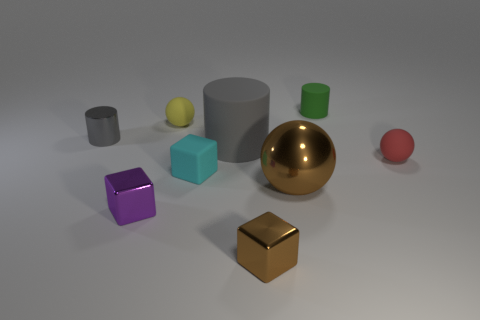What is the small object that is left of the small cyan matte cube and in front of the small gray object made of?
Offer a terse response. Metal. The big shiny ball has what color?
Provide a short and direct response. Brown. Are there more tiny cyan objects in front of the metal cylinder than large gray objects that are behind the big matte cylinder?
Make the answer very short. Yes. The rubber cylinder that is in front of the tiny gray metal thing is what color?
Your answer should be compact. Gray. Do the gray thing that is right of the small yellow rubber ball and the ball left of the big gray matte thing have the same size?
Make the answer very short. No. What number of objects are yellow matte things or small red matte spheres?
Make the answer very short. 2. The tiny sphere on the left side of the small cube that is behind the large brown ball is made of what material?
Your response must be concise. Rubber. What number of tiny blue things have the same shape as the tiny red matte thing?
Provide a short and direct response. 0. Are there any metallic cylinders that have the same color as the shiny ball?
Your answer should be very brief. No. What number of objects are either small rubber objects that are on the right side of the small rubber cylinder or shiny objects that are on the right side of the gray metallic cylinder?
Offer a terse response. 4. 